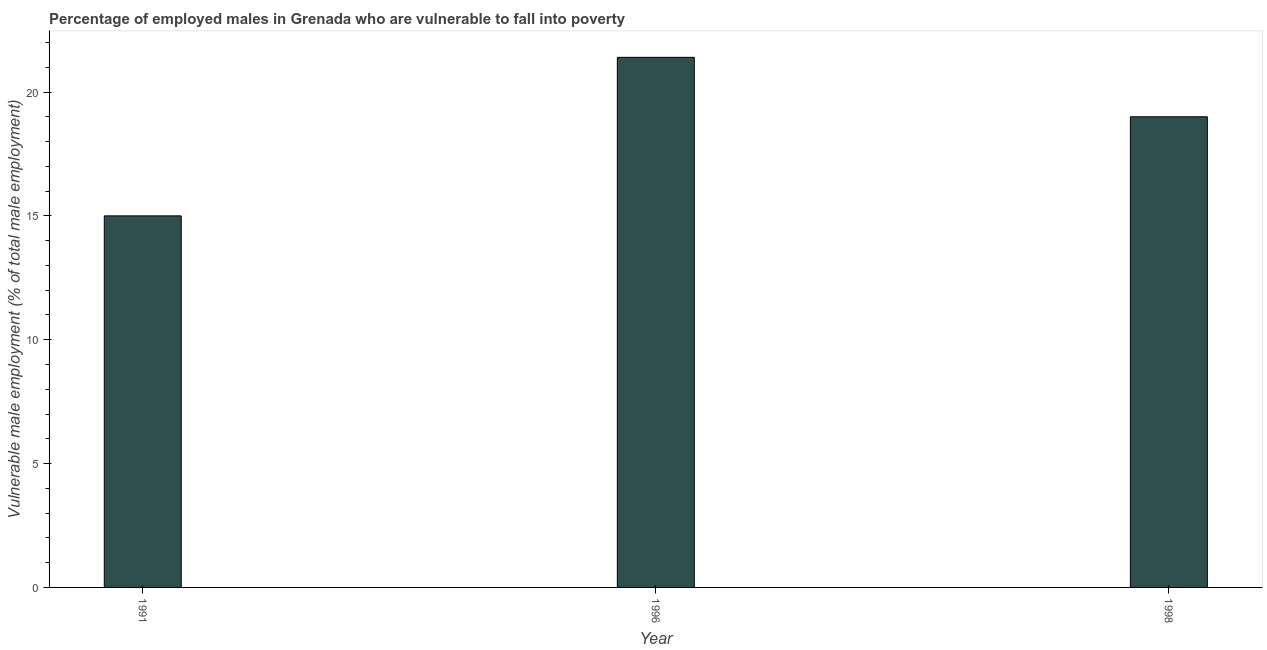Does the graph contain any zero values?
Offer a very short reply. No. Does the graph contain grids?
Offer a very short reply. No. What is the title of the graph?
Make the answer very short. Percentage of employed males in Grenada who are vulnerable to fall into poverty. What is the label or title of the Y-axis?
Ensure brevity in your answer.  Vulnerable male employment (% of total male employment). What is the percentage of employed males who are vulnerable to fall into poverty in 1996?
Keep it short and to the point. 21.4. Across all years, what is the maximum percentage of employed males who are vulnerable to fall into poverty?
Offer a terse response. 21.4. Across all years, what is the minimum percentage of employed males who are vulnerable to fall into poverty?
Offer a terse response. 15. What is the sum of the percentage of employed males who are vulnerable to fall into poverty?
Your answer should be very brief. 55.4. What is the average percentage of employed males who are vulnerable to fall into poverty per year?
Your answer should be very brief. 18.47. In how many years, is the percentage of employed males who are vulnerable to fall into poverty greater than 11 %?
Your answer should be very brief. 3. Do a majority of the years between 1998 and 1996 (inclusive) have percentage of employed males who are vulnerable to fall into poverty greater than 11 %?
Keep it short and to the point. No. What is the ratio of the percentage of employed males who are vulnerable to fall into poverty in 1991 to that in 1996?
Provide a short and direct response. 0.7. What is the difference between the highest and the lowest percentage of employed males who are vulnerable to fall into poverty?
Give a very brief answer. 6.4. Are all the bars in the graph horizontal?
Give a very brief answer. No. How many years are there in the graph?
Provide a succinct answer. 3. Are the values on the major ticks of Y-axis written in scientific E-notation?
Offer a very short reply. No. What is the Vulnerable male employment (% of total male employment) in 1996?
Your response must be concise. 21.4. What is the difference between the Vulnerable male employment (% of total male employment) in 1996 and 1998?
Provide a short and direct response. 2.4. What is the ratio of the Vulnerable male employment (% of total male employment) in 1991 to that in 1996?
Offer a terse response. 0.7. What is the ratio of the Vulnerable male employment (% of total male employment) in 1991 to that in 1998?
Keep it short and to the point. 0.79. What is the ratio of the Vulnerable male employment (% of total male employment) in 1996 to that in 1998?
Give a very brief answer. 1.13. 